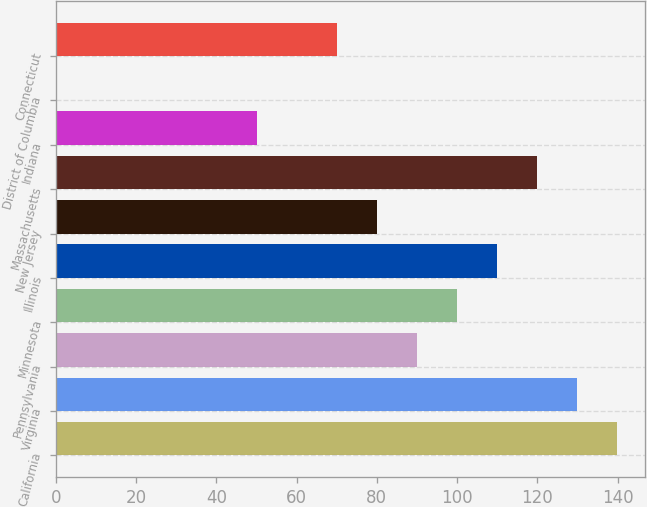Convert chart to OTSL. <chart><loc_0><loc_0><loc_500><loc_500><bar_chart><fcel>California<fcel>Virginia<fcel>Pennsylvania<fcel>Minnesota<fcel>Illinois<fcel>New Jersey<fcel>Massachusetts<fcel>Indiana<fcel>District of Columbia<fcel>Connecticut<nl><fcel>139.88<fcel>129.91<fcel>90.03<fcel>100<fcel>109.97<fcel>80.06<fcel>119.94<fcel>50.15<fcel>0.3<fcel>70.09<nl></chart> 